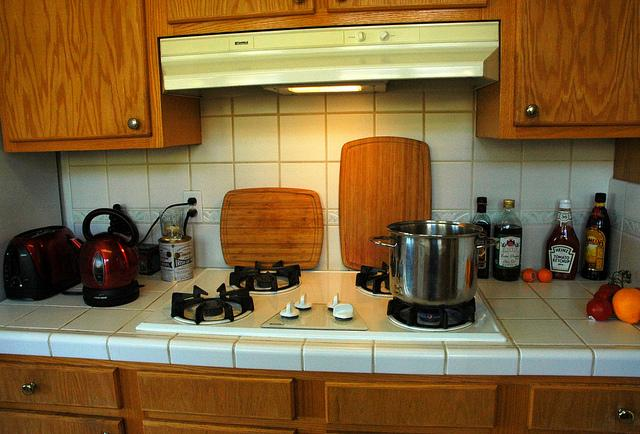What is a favorite condiment of the owner? ketchup 